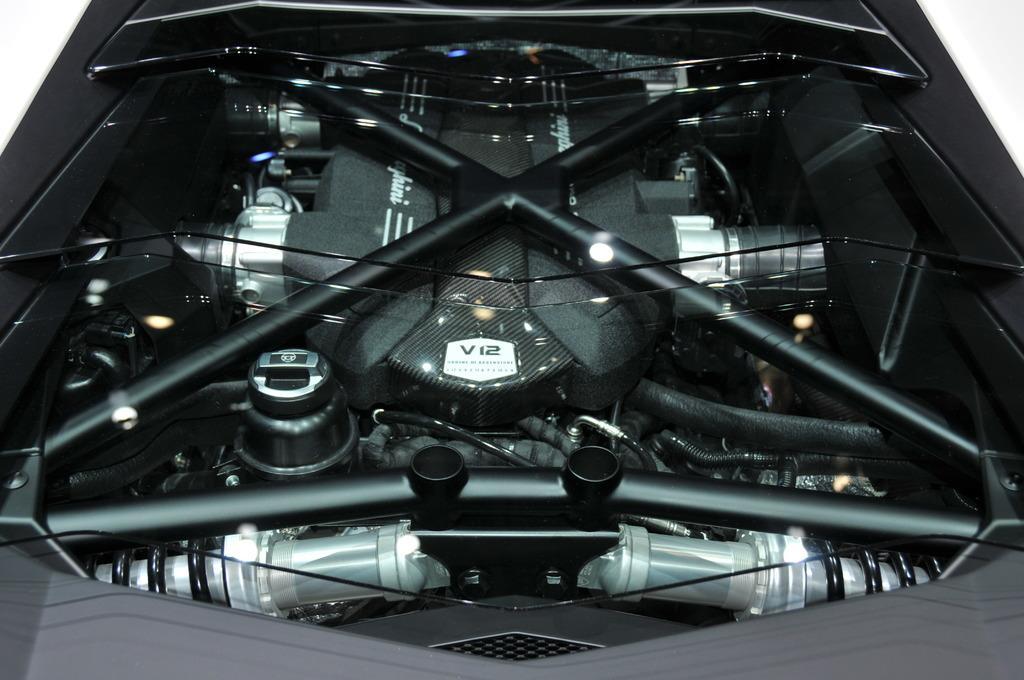Describe this image in one or two sentences. In this image in the center it might be a vehicle's engine, and there is a white background. 